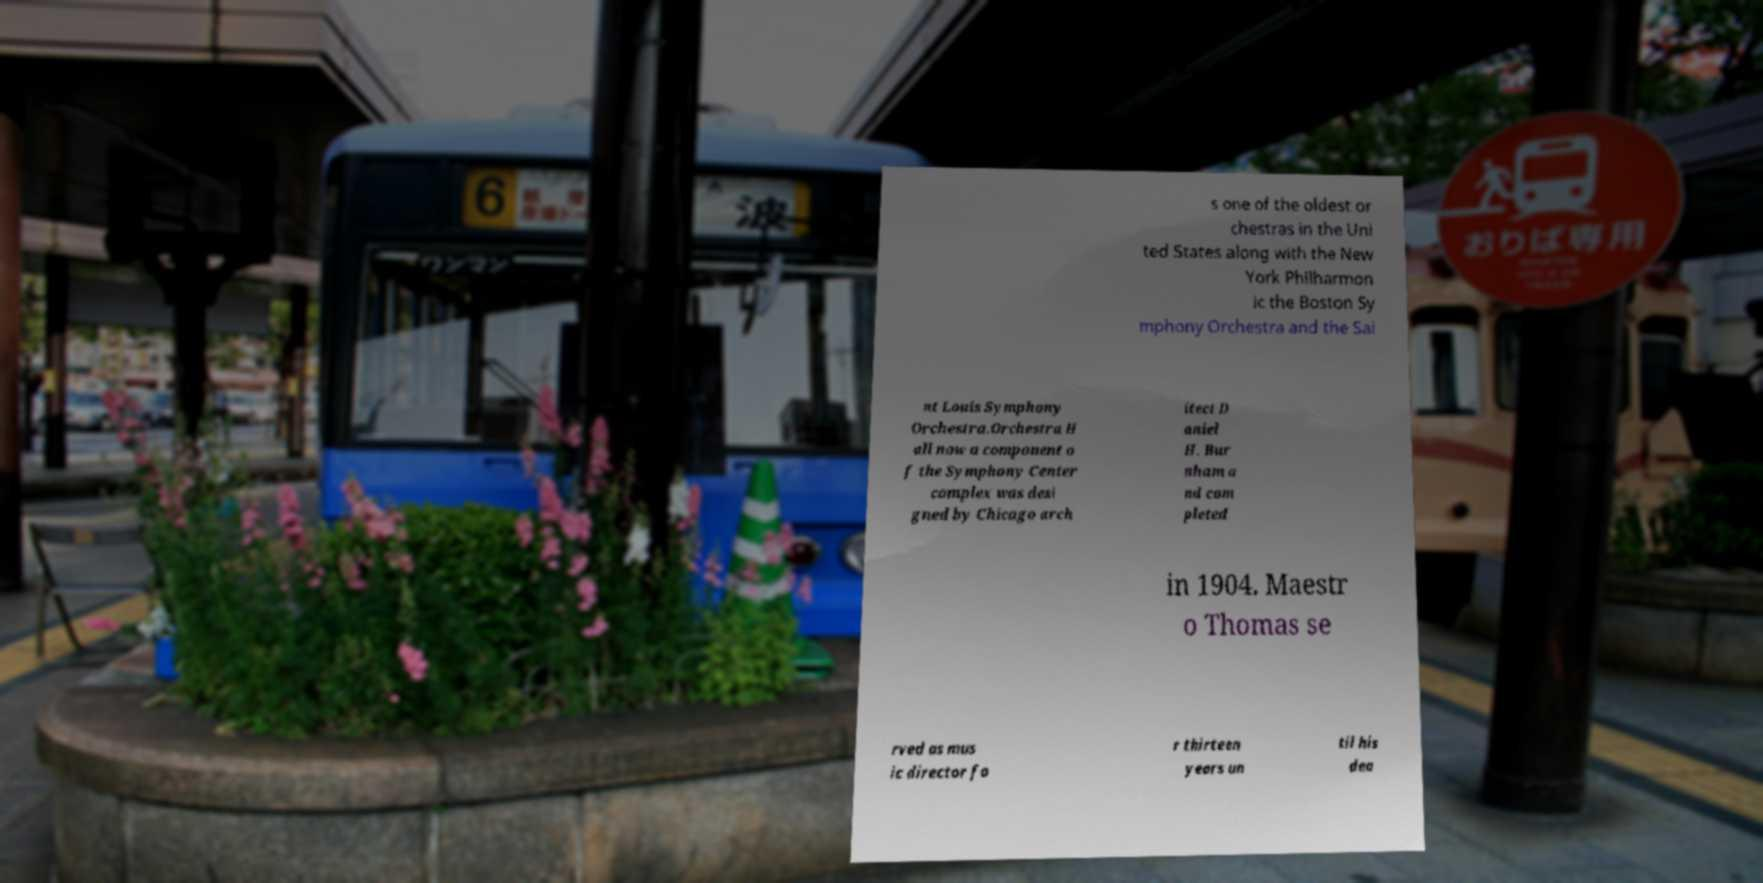Please identify and transcribe the text found in this image. s one of the oldest or chestras in the Uni ted States along with the New York Philharmon ic the Boston Sy mphony Orchestra and the Sai nt Louis Symphony Orchestra.Orchestra H all now a component o f the Symphony Center complex was desi gned by Chicago arch itect D aniel H. Bur nham a nd com pleted in 1904. Maestr o Thomas se rved as mus ic director fo r thirteen years un til his dea 